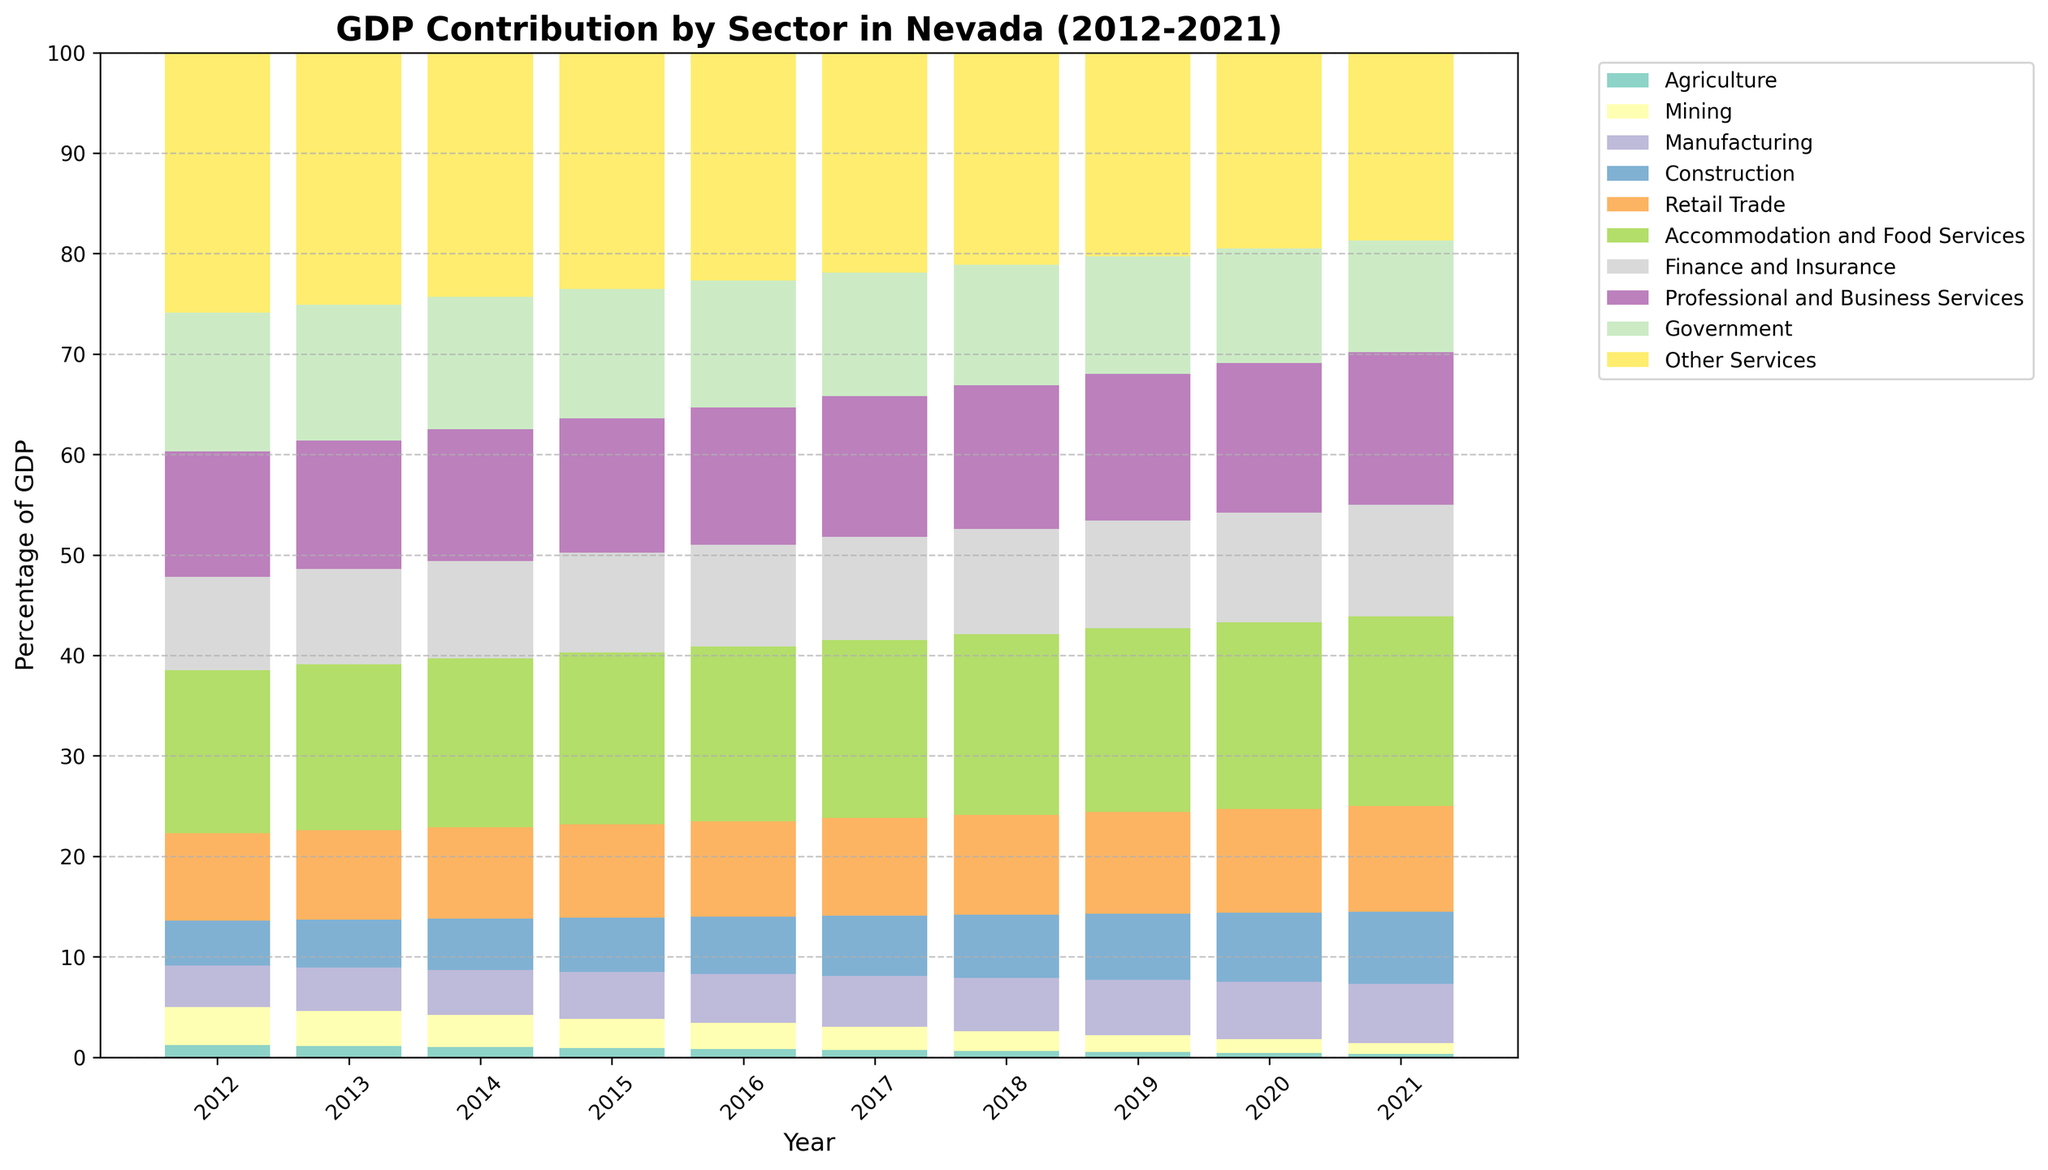What sector had the highest GDP contribution in 2021? By looking at the topmost segment of the bars in 2021, the tallest segment that contributes the most to the GDP is "Other Services".
Answer: Other Services Which sector's contribution declined the most from 2012 to 2021? By comparing the height of the segments from 2012 to 2021, "Mining" shows the most significant decline. It went from 3.8% in 2012 to 1.1% in 2021.
Answer: Mining What is the sum of the GDP contributions of Agriculture and Mining in 2015? Look at the Agriculture and Mining segments in 2015 and add their contributions: 0.9% (Agriculture) + 2.9% (Mining) = 3.8%.
Answer: 3.8% Has the contribution of Accommodation and Food Services increased or decreased over the decade? By observing the Accommodation and Food Services segments from 2012 to 2021, we can see the segment consistently increases every year.
Answer: Increased What is the average GDP contribution of the Construction sector from 2012 to 2021? Sum the annual GDP contributions of Construction from 2012 to 2021 and divide by the number of years: (4.5 + 4.8 + 5.1 + 5.4 + 5.7 + 6.0 + 6.3 + 6.6 + 6.9 + 7.2) / 10 = 5.85%.
Answer: 5.85% In which year did the Manufacturing sector experience the highest GDP contribution? Identify the year in which the Manufacturing segment reached its peak height. It peaks at 5.9% in 2021.
Answer: 2021 How did the Agriculture sector's contribution as a percentage of GDP change from 2012 to 2021? Compare the height of the Agriculture segments between 2012 and 2021. It decreased from 1.2% in 2012 to 0.3% in 2021.
Answer: Decreased How does the 2012 GDP contribution of Professional and Business Services compare with that of Finance and Insurance in 2021? Compare the heights of Professional and Business Services in 2012 (12.5%) with Finance and Insurance in 2021 (11.1%). Professional and Business Services had a higher contribution in 2012.
Answer: Professional and Business Services had a higher contribution in 2012 Which sector had the least variation in GDP contribution over the decade, and what was its range of variation? By looking at the overall stability of each segment, Finance and Insurance appears to vary the least. The range is calculated by maximum minus minimum: 11.1% - 9.3% = 1.8%.
Answer: Finance and Insurance, 1.8% What is the combined GDP contribution of the Retail Trade and Government sectors in 2017? Sum the contributions of Retail Trade and Government in 2017: 9.7% (Retail Trade) + 12.3% (Government) = 22%.
Answer: 22% 